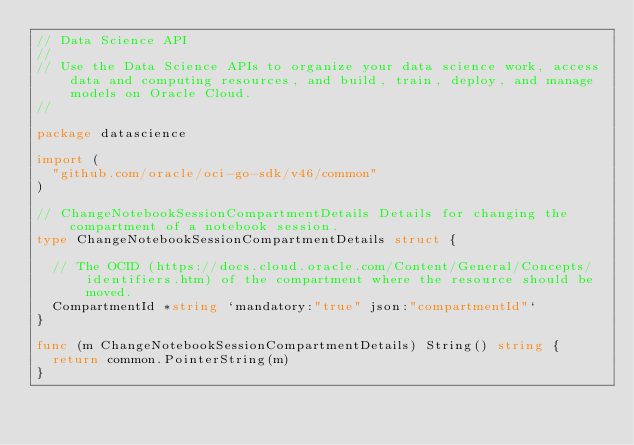Convert code to text. <code><loc_0><loc_0><loc_500><loc_500><_Go_>// Data Science API
//
// Use the Data Science APIs to organize your data science work, access data and computing resources, and build, train, deploy, and manage models on Oracle Cloud.
//

package datascience

import (
	"github.com/oracle/oci-go-sdk/v46/common"
)

// ChangeNotebookSessionCompartmentDetails Details for changing the compartment of a notebook session.
type ChangeNotebookSessionCompartmentDetails struct {

	// The OCID (https://docs.cloud.oracle.com/Content/General/Concepts/identifiers.htm) of the compartment where the resource should be moved.
	CompartmentId *string `mandatory:"true" json:"compartmentId"`
}

func (m ChangeNotebookSessionCompartmentDetails) String() string {
	return common.PointerString(m)
}
</code> 